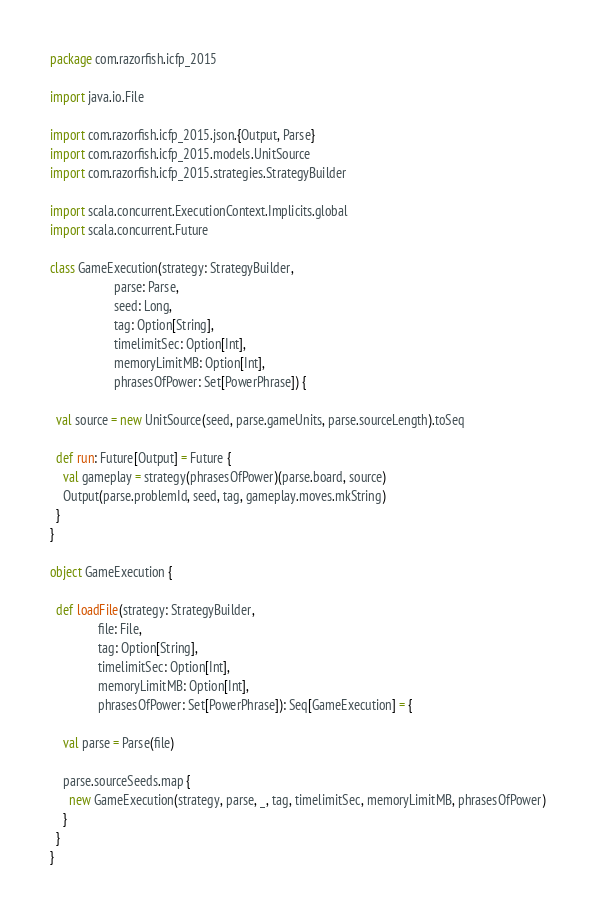<code> <loc_0><loc_0><loc_500><loc_500><_Scala_>package com.razorfish.icfp_2015

import java.io.File

import com.razorfish.icfp_2015.json.{Output, Parse}
import com.razorfish.icfp_2015.models.UnitSource
import com.razorfish.icfp_2015.strategies.StrategyBuilder

import scala.concurrent.ExecutionContext.Implicits.global
import scala.concurrent.Future

class GameExecution(strategy: StrategyBuilder,
                    parse: Parse,
                    seed: Long,
                    tag: Option[String],
                    timelimitSec: Option[Int],
                    memoryLimitMB: Option[Int],
                    phrasesOfPower: Set[PowerPhrase]) {

  val source = new UnitSource(seed, parse.gameUnits, parse.sourceLength).toSeq

  def run: Future[Output] = Future {
    val gameplay = strategy(phrasesOfPower)(parse.board, source)
    Output(parse.problemId, seed, tag, gameplay.moves.mkString)
  }
}

object GameExecution {

  def loadFile(strategy: StrategyBuilder,
               file: File,
               tag: Option[String],
               timelimitSec: Option[Int],
               memoryLimitMB: Option[Int],
               phrasesOfPower: Set[PowerPhrase]): Seq[GameExecution] = {

    val parse = Parse(file)

    parse.sourceSeeds.map {
      new GameExecution(strategy, parse, _, tag, timelimitSec, memoryLimitMB, phrasesOfPower)
    }
  }
}

</code> 